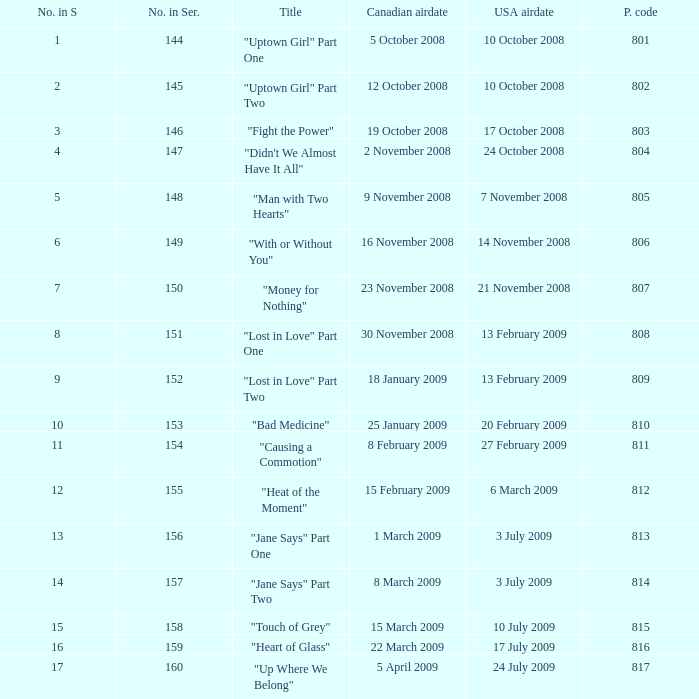What is the latest season number for a show with a production code of 816? 16.0. 